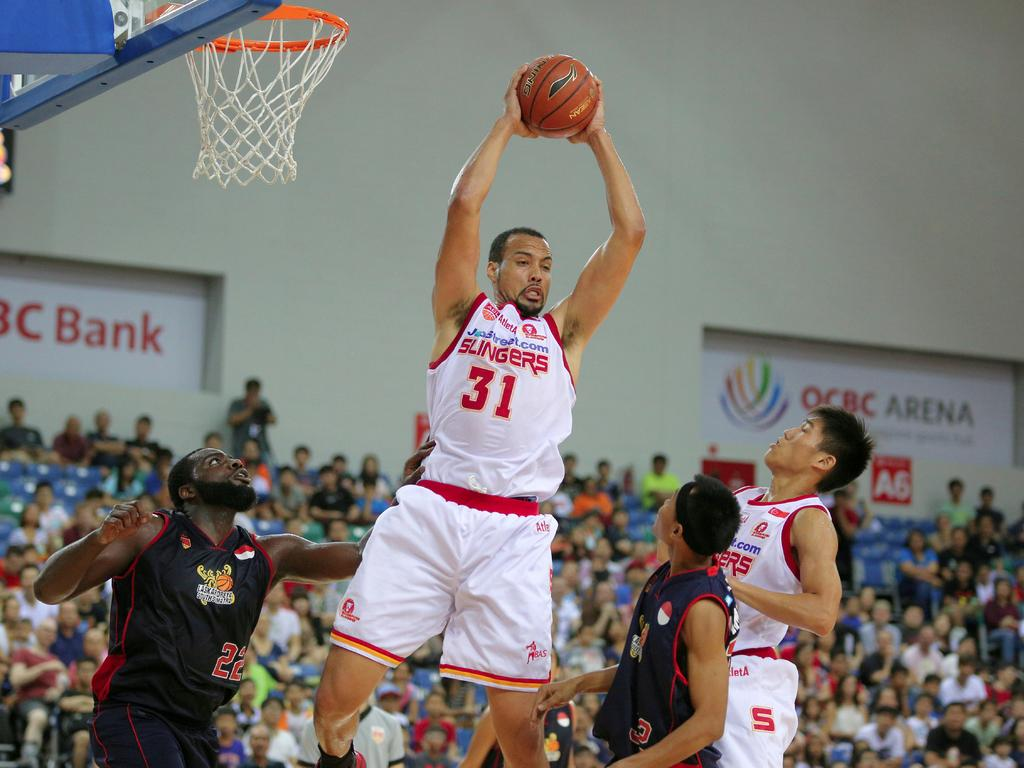Provide a one-sentence caption for the provided image. Player number 31 for the Slingers grabbing a rebound. 